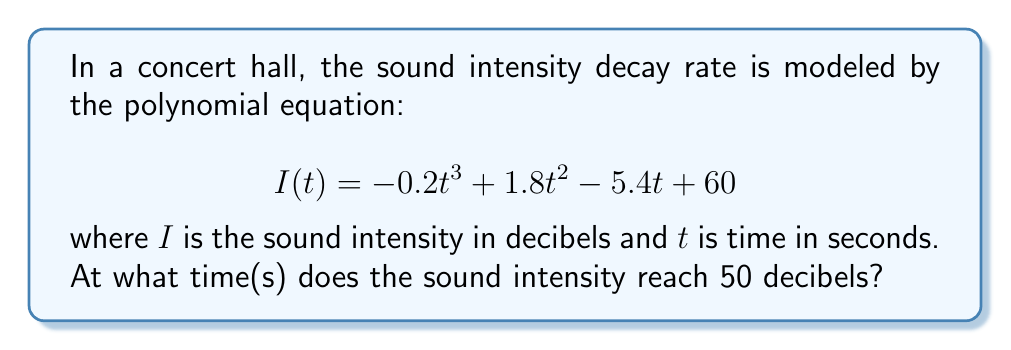Can you answer this question? To solve this problem, we need to find the roots of the equation:

$$-0.2t^3 + 1.8t^2 - 5.4t + 60 = 50$$

1. Rearrange the equation to standard form:
   $$-0.2t^3 + 1.8t^2 - 5.4t + 10 = 0$$

2. Multiply all terms by -5 to eliminate fractions:
   $$t^3 - 9t^2 + 27t - 50 = 0$$

3. This is a cubic equation. Let's try to factor it:
   $$(t - 5)(t^2 - 4t + 10) = 0$$

4. Solve each factor:
   a) $t - 5 = 0$
      $t = 5$
   
   b) $t^2 - 4t + 10 = 0$
      Using the quadratic formula: $t = \frac{-b \pm \sqrt{b^2 - 4ac}}{2a}$
      $t = \frac{4 \pm \sqrt{16 - 40}}{2} = \frac{4 \pm \sqrt{-24}}{2}$
      This has no real solutions.

5. Therefore, the only real solution is $t = 5$ seconds.
Answer: $t = 5$ seconds 